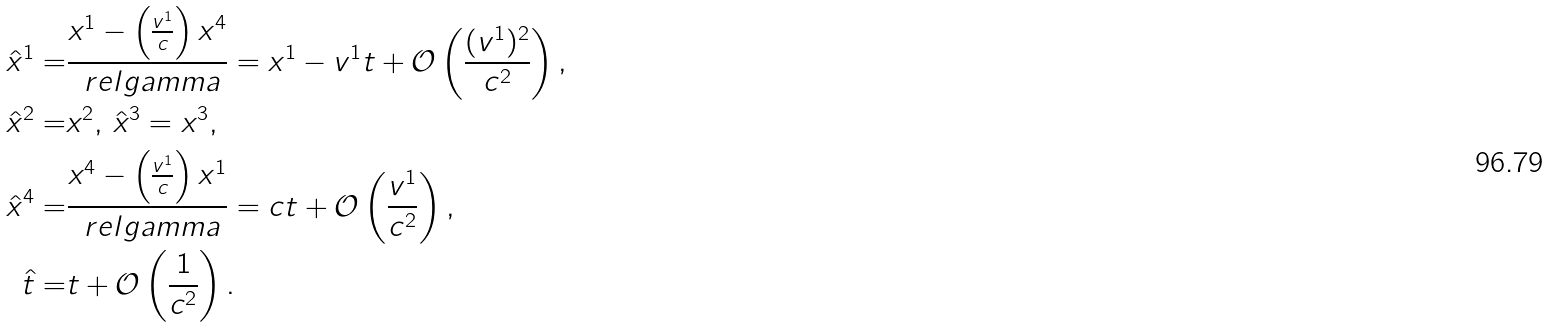<formula> <loc_0><loc_0><loc_500><loc_500>\hat { x } ^ { 1 } = & \frac { x ^ { 1 } - \left ( \frac { v ^ { 1 } } { c } \right ) x ^ { 4 } } { \ r e l g a m m a } = x ^ { 1 } - v ^ { 1 } t + \mathcal { O } \left ( \frac { ( v ^ { 1 } ) ^ { 2 } } { c ^ { 2 } } \right ) , \\ \hat { x } ^ { 2 } = & x ^ { 2 } , \, \hat { x } ^ { 3 } = x ^ { 3 } , \\ \hat { x } ^ { 4 } = & \frac { x ^ { 4 } - \left ( \frac { v ^ { 1 } } { c } \right ) x ^ { 1 } } { \ r e l g a m m a } = c t + \mathcal { O } \left ( \frac { v ^ { 1 } } { c ^ { 2 } } \right ) , \\ \hat { t } = & t + \mathcal { O } \left ( \frac { 1 } { c ^ { 2 } } \right ) .</formula> 